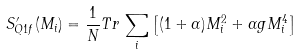Convert formula to latex. <formula><loc_0><loc_0><loc_500><loc_500>S ^ { \prime } _ { Q 1 f } ( M _ { i } ) = \frac { 1 } { N } T r \, \sum _ { i } \left [ ( 1 + \alpha ) M _ { i } ^ { 2 } + \alpha g M _ { i } ^ { 4 } \right ]</formula> 